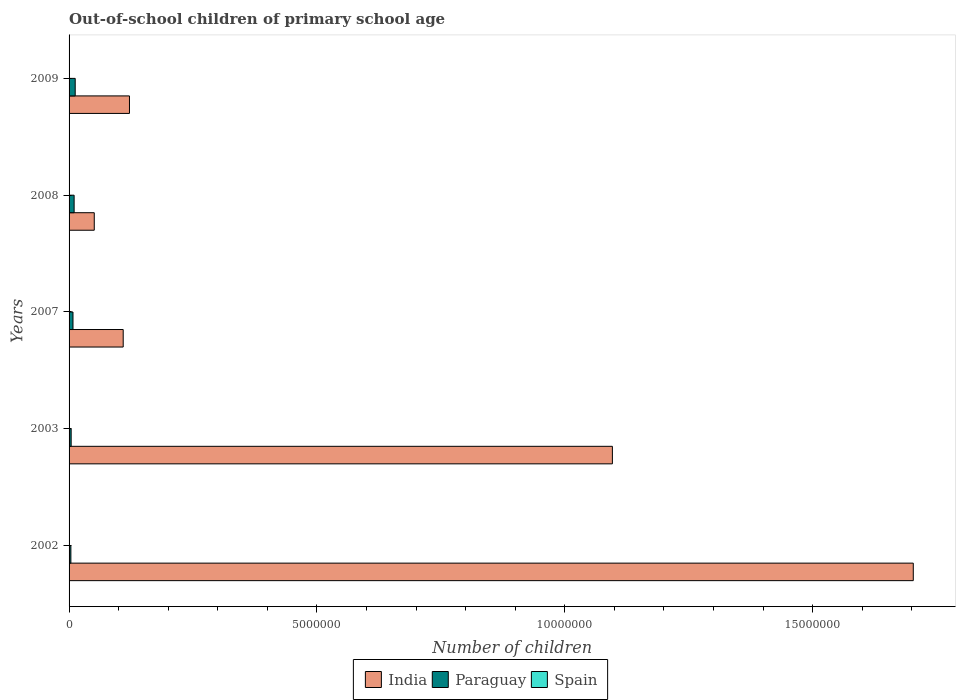How many groups of bars are there?
Offer a very short reply. 5. Are the number of bars per tick equal to the number of legend labels?
Your answer should be compact. Yes. Are the number of bars on each tick of the Y-axis equal?
Keep it short and to the point. Yes. How many bars are there on the 2nd tick from the top?
Provide a short and direct response. 3. How many bars are there on the 2nd tick from the bottom?
Keep it short and to the point. 3. What is the number of out-of-school children in India in 2002?
Make the answer very short. 1.70e+07. Across all years, what is the maximum number of out-of-school children in Paraguay?
Give a very brief answer. 1.24e+05. Across all years, what is the minimum number of out-of-school children in Spain?
Provide a succinct answer. 2757. In which year was the number of out-of-school children in India maximum?
Offer a terse response. 2002. What is the total number of out-of-school children in India in the graph?
Give a very brief answer. 3.08e+07. What is the difference between the number of out-of-school children in Paraguay in 2007 and that in 2009?
Offer a terse response. -4.46e+04. What is the difference between the number of out-of-school children in Paraguay in 2008 and the number of out-of-school children in India in 2002?
Make the answer very short. -1.69e+07. What is the average number of out-of-school children in India per year?
Offer a terse response. 6.16e+06. In the year 2002, what is the difference between the number of out-of-school children in India and number of out-of-school children in Paraguay?
Your response must be concise. 1.70e+07. In how many years, is the number of out-of-school children in Paraguay greater than 10000000 ?
Give a very brief answer. 0. What is the ratio of the number of out-of-school children in Spain in 2002 to that in 2007?
Keep it short and to the point. 0.52. Is the difference between the number of out-of-school children in India in 2003 and 2009 greater than the difference between the number of out-of-school children in Paraguay in 2003 and 2009?
Your response must be concise. Yes. What is the difference between the highest and the second highest number of out-of-school children in Paraguay?
Offer a very short reply. 2.17e+04. What is the difference between the highest and the lowest number of out-of-school children in Paraguay?
Your answer should be compact. 8.74e+04. In how many years, is the number of out-of-school children in India greater than the average number of out-of-school children in India taken over all years?
Offer a terse response. 2. Is the sum of the number of out-of-school children in India in 2002 and 2009 greater than the maximum number of out-of-school children in Spain across all years?
Your answer should be compact. Yes. What does the 3rd bar from the top in 2008 represents?
Ensure brevity in your answer.  India. What does the 3rd bar from the bottom in 2009 represents?
Ensure brevity in your answer.  Spain. How many bars are there?
Make the answer very short. 15. Are all the bars in the graph horizontal?
Offer a terse response. Yes. How many years are there in the graph?
Your response must be concise. 5. Does the graph contain any zero values?
Ensure brevity in your answer.  No. Where does the legend appear in the graph?
Offer a terse response. Bottom center. How many legend labels are there?
Make the answer very short. 3. What is the title of the graph?
Keep it short and to the point. Out-of-school children of primary school age. What is the label or title of the X-axis?
Provide a succinct answer. Number of children. What is the Number of children in India in 2002?
Provide a short and direct response. 1.70e+07. What is the Number of children of Paraguay in 2002?
Provide a short and direct response. 3.63e+04. What is the Number of children of Spain in 2002?
Your response must be concise. 2757. What is the Number of children in India in 2003?
Your response must be concise. 1.10e+07. What is the Number of children of Paraguay in 2003?
Ensure brevity in your answer.  4.20e+04. What is the Number of children in Spain in 2003?
Your response must be concise. 4811. What is the Number of children of India in 2007?
Provide a succinct answer. 1.09e+06. What is the Number of children in Paraguay in 2007?
Offer a terse response. 7.90e+04. What is the Number of children of Spain in 2007?
Provide a short and direct response. 5316. What is the Number of children of India in 2008?
Offer a very short reply. 5.08e+05. What is the Number of children in Paraguay in 2008?
Provide a short and direct response. 1.02e+05. What is the Number of children in Spain in 2008?
Give a very brief answer. 4170. What is the Number of children of India in 2009?
Provide a short and direct response. 1.22e+06. What is the Number of children of Paraguay in 2009?
Ensure brevity in your answer.  1.24e+05. What is the Number of children in Spain in 2009?
Keep it short and to the point. 2853. Across all years, what is the maximum Number of children in India?
Ensure brevity in your answer.  1.70e+07. Across all years, what is the maximum Number of children of Paraguay?
Provide a succinct answer. 1.24e+05. Across all years, what is the maximum Number of children of Spain?
Your response must be concise. 5316. Across all years, what is the minimum Number of children of India?
Give a very brief answer. 5.08e+05. Across all years, what is the minimum Number of children in Paraguay?
Offer a terse response. 3.63e+04. Across all years, what is the minimum Number of children in Spain?
Your answer should be compact. 2757. What is the total Number of children in India in the graph?
Give a very brief answer. 3.08e+07. What is the total Number of children in Paraguay in the graph?
Provide a succinct answer. 3.83e+05. What is the total Number of children in Spain in the graph?
Your response must be concise. 1.99e+04. What is the difference between the Number of children in India in 2002 and that in 2003?
Make the answer very short. 6.07e+06. What is the difference between the Number of children of Paraguay in 2002 and that in 2003?
Offer a very short reply. -5724. What is the difference between the Number of children in Spain in 2002 and that in 2003?
Provide a succinct answer. -2054. What is the difference between the Number of children in India in 2002 and that in 2007?
Provide a short and direct response. 1.59e+07. What is the difference between the Number of children in Paraguay in 2002 and that in 2007?
Give a very brief answer. -4.28e+04. What is the difference between the Number of children of Spain in 2002 and that in 2007?
Provide a short and direct response. -2559. What is the difference between the Number of children in India in 2002 and that in 2008?
Your response must be concise. 1.65e+07. What is the difference between the Number of children in Paraguay in 2002 and that in 2008?
Provide a short and direct response. -6.57e+04. What is the difference between the Number of children of Spain in 2002 and that in 2008?
Offer a very short reply. -1413. What is the difference between the Number of children in India in 2002 and that in 2009?
Keep it short and to the point. 1.58e+07. What is the difference between the Number of children in Paraguay in 2002 and that in 2009?
Provide a succinct answer. -8.74e+04. What is the difference between the Number of children in Spain in 2002 and that in 2009?
Offer a very short reply. -96. What is the difference between the Number of children in India in 2003 and that in 2007?
Provide a short and direct response. 9.87e+06. What is the difference between the Number of children in Paraguay in 2003 and that in 2007?
Your answer should be compact. -3.70e+04. What is the difference between the Number of children of Spain in 2003 and that in 2007?
Your answer should be very brief. -505. What is the difference between the Number of children in India in 2003 and that in 2008?
Offer a terse response. 1.05e+07. What is the difference between the Number of children in Paraguay in 2003 and that in 2008?
Provide a short and direct response. -5.99e+04. What is the difference between the Number of children in Spain in 2003 and that in 2008?
Offer a terse response. 641. What is the difference between the Number of children in India in 2003 and that in 2009?
Give a very brief answer. 9.74e+06. What is the difference between the Number of children of Paraguay in 2003 and that in 2009?
Provide a succinct answer. -8.16e+04. What is the difference between the Number of children of Spain in 2003 and that in 2009?
Keep it short and to the point. 1958. What is the difference between the Number of children in India in 2007 and that in 2008?
Ensure brevity in your answer.  5.84e+05. What is the difference between the Number of children of Paraguay in 2007 and that in 2008?
Offer a very short reply. -2.29e+04. What is the difference between the Number of children of Spain in 2007 and that in 2008?
Offer a very short reply. 1146. What is the difference between the Number of children of India in 2007 and that in 2009?
Provide a succinct answer. -1.26e+05. What is the difference between the Number of children in Paraguay in 2007 and that in 2009?
Your response must be concise. -4.46e+04. What is the difference between the Number of children of Spain in 2007 and that in 2009?
Give a very brief answer. 2463. What is the difference between the Number of children in India in 2008 and that in 2009?
Provide a short and direct response. -7.10e+05. What is the difference between the Number of children of Paraguay in 2008 and that in 2009?
Give a very brief answer. -2.17e+04. What is the difference between the Number of children of Spain in 2008 and that in 2009?
Keep it short and to the point. 1317. What is the difference between the Number of children in India in 2002 and the Number of children in Paraguay in 2003?
Keep it short and to the point. 1.70e+07. What is the difference between the Number of children in India in 2002 and the Number of children in Spain in 2003?
Your answer should be very brief. 1.70e+07. What is the difference between the Number of children in Paraguay in 2002 and the Number of children in Spain in 2003?
Your response must be concise. 3.15e+04. What is the difference between the Number of children in India in 2002 and the Number of children in Paraguay in 2007?
Your answer should be very brief. 1.70e+07. What is the difference between the Number of children in India in 2002 and the Number of children in Spain in 2007?
Your response must be concise. 1.70e+07. What is the difference between the Number of children of Paraguay in 2002 and the Number of children of Spain in 2007?
Provide a short and direct response. 3.10e+04. What is the difference between the Number of children of India in 2002 and the Number of children of Paraguay in 2008?
Give a very brief answer. 1.69e+07. What is the difference between the Number of children in India in 2002 and the Number of children in Spain in 2008?
Offer a terse response. 1.70e+07. What is the difference between the Number of children of Paraguay in 2002 and the Number of children of Spain in 2008?
Your answer should be compact. 3.21e+04. What is the difference between the Number of children in India in 2002 and the Number of children in Paraguay in 2009?
Keep it short and to the point. 1.69e+07. What is the difference between the Number of children in India in 2002 and the Number of children in Spain in 2009?
Ensure brevity in your answer.  1.70e+07. What is the difference between the Number of children in Paraguay in 2002 and the Number of children in Spain in 2009?
Your response must be concise. 3.34e+04. What is the difference between the Number of children of India in 2003 and the Number of children of Paraguay in 2007?
Make the answer very short. 1.09e+07. What is the difference between the Number of children of India in 2003 and the Number of children of Spain in 2007?
Make the answer very short. 1.10e+07. What is the difference between the Number of children in Paraguay in 2003 and the Number of children in Spain in 2007?
Make the answer very short. 3.67e+04. What is the difference between the Number of children of India in 2003 and the Number of children of Paraguay in 2008?
Make the answer very short. 1.09e+07. What is the difference between the Number of children of India in 2003 and the Number of children of Spain in 2008?
Provide a succinct answer. 1.10e+07. What is the difference between the Number of children of Paraguay in 2003 and the Number of children of Spain in 2008?
Offer a terse response. 3.79e+04. What is the difference between the Number of children of India in 2003 and the Number of children of Paraguay in 2009?
Your answer should be compact. 1.08e+07. What is the difference between the Number of children in India in 2003 and the Number of children in Spain in 2009?
Make the answer very short. 1.10e+07. What is the difference between the Number of children in Paraguay in 2003 and the Number of children in Spain in 2009?
Offer a very short reply. 3.92e+04. What is the difference between the Number of children in India in 2007 and the Number of children in Paraguay in 2008?
Offer a very short reply. 9.90e+05. What is the difference between the Number of children of India in 2007 and the Number of children of Spain in 2008?
Provide a succinct answer. 1.09e+06. What is the difference between the Number of children of Paraguay in 2007 and the Number of children of Spain in 2008?
Keep it short and to the point. 7.49e+04. What is the difference between the Number of children in India in 2007 and the Number of children in Paraguay in 2009?
Ensure brevity in your answer.  9.68e+05. What is the difference between the Number of children in India in 2007 and the Number of children in Spain in 2009?
Make the answer very short. 1.09e+06. What is the difference between the Number of children in Paraguay in 2007 and the Number of children in Spain in 2009?
Provide a short and direct response. 7.62e+04. What is the difference between the Number of children in India in 2008 and the Number of children in Paraguay in 2009?
Offer a very short reply. 3.84e+05. What is the difference between the Number of children of India in 2008 and the Number of children of Spain in 2009?
Offer a terse response. 5.05e+05. What is the difference between the Number of children in Paraguay in 2008 and the Number of children in Spain in 2009?
Keep it short and to the point. 9.91e+04. What is the average Number of children of India per year?
Make the answer very short. 6.16e+06. What is the average Number of children of Paraguay per year?
Offer a terse response. 7.66e+04. What is the average Number of children of Spain per year?
Offer a terse response. 3981.4. In the year 2002, what is the difference between the Number of children in India and Number of children in Paraguay?
Give a very brief answer. 1.70e+07. In the year 2002, what is the difference between the Number of children in India and Number of children in Spain?
Make the answer very short. 1.70e+07. In the year 2002, what is the difference between the Number of children in Paraguay and Number of children in Spain?
Provide a short and direct response. 3.35e+04. In the year 2003, what is the difference between the Number of children of India and Number of children of Paraguay?
Your response must be concise. 1.09e+07. In the year 2003, what is the difference between the Number of children of India and Number of children of Spain?
Keep it short and to the point. 1.10e+07. In the year 2003, what is the difference between the Number of children of Paraguay and Number of children of Spain?
Provide a succinct answer. 3.72e+04. In the year 2007, what is the difference between the Number of children in India and Number of children in Paraguay?
Your answer should be compact. 1.01e+06. In the year 2007, what is the difference between the Number of children in India and Number of children in Spain?
Ensure brevity in your answer.  1.09e+06. In the year 2007, what is the difference between the Number of children of Paraguay and Number of children of Spain?
Offer a very short reply. 7.37e+04. In the year 2008, what is the difference between the Number of children in India and Number of children in Paraguay?
Make the answer very short. 4.06e+05. In the year 2008, what is the difference between the Number of children of India and Number of children of Spain?
Give a very brief answer. 5.04e+05. In the year 2008, what is the difference between the Number of children of Paraguay and Number of children of Spain?
Offer a very short reply. 9.78e+04. In the year 2009, what is the difference between the Number of children of India and Number of children of Paraguay?
Give a very brief answer. 1.09e+06. In the year 2009, what is the difference between the Number of children of India and Number of children of Spain?
Your response must be concise. 1.22e+06. In the year 2009, what is the difference between the Number of children in Paraguay and Number of children in Spain?
Ensure brevity in your answer.  1.21e+05. What is the ratio of the Number of children of India in 2002 to that in 2003?
Give a very brief answer. 1.55. What is the ratio of the Number of children of Paraguay in 2002 to that in 2003?
Provide a succinct answer. 0.86. What is the ratio of the Number of children of Spain in 2002 to that in 2003?
Offer a very short reply. 0.57. What is the ratio of the Number of children in India in 2002 to that in 2007?
Your answer should be compact. 15.6. What is the ratio of the Number of children of Paraguay in 2002 to that in 2007?
Offer a very short reply. 0.46. What is the ratio of the Number of children in Spain in 2002 to that in 2007?
Offer a terse response. 0.52. What is the ratio of the Number of children in India in 2002 to that in 2008?
Your answer should be very brief. 33.52. What is the ratio of the Number of children of Paraguay in 2002 to that in 2008?
Provide a succinct answer. 0.36. What is the ratio of the Number of children of Spain in 2002 to that in 2008?
Give a very brief answer. 0.66. What is the ratio of the Number of children of India in 2002 to that in 2009?
Offer a very short reply. 13.98. What is the ratio of the Number of children in Paraguay in 2002 to that in 2009?
Ensure brevity in your answer.  0.29. What is the ratio of the Number of children of Spain in 2002 to that in 2009?
Keep it short and to the point. 0.97. What is the ratio of the Number of children in India in 2003 to that in 2007?
Offer a very short reply. 10.04. What is the ratio of the Number of children in Paraguay in 2003 to that in 2007?
Provide a short and direct response. 0.53. What is the ratio of the Number of children of Spain in 2003 to that in 2007?
Offer a terse response. 0.91. What is the ratio of the Number of children of India in 2003 to that in 2008?
Make the answer very short. 21.57. What is the ratio of the Number of children in Paraguay in 2003 to that in 2008?
Your answer should be very brief. 0.41. What is the ratio of the Number of children in Spain in 2003 to that in 2008?
Provide a succinct answer. 1.15. What is the ratio of the Number of children of India in 2003 to that in 2009?
Give a very brief answer. 9. What is the ratio of the Number of children in Paraguay in 2003 to that in 2009?
Your answer should be compact. 0.34. What is the ratio of the Number of children in Spain in 2003 to that in 2009?
Keep it short and to the point. 1.69. What is the ratio of the Number of children of India in 2007 to that in 2008?
Ensure brevity in your answer.  2.15. What is the ratio of the Number of children of Paraguay in 2007 to that in 2008?
Provide a short and direct response. 0.78. What is the ratio of the Number of children of Spain in 2007 to that in 2008?
Your answer should be very brief. 1.27. What is the ratio of the Number of children of India in 2007 to that in 2009?
Make the answer very short. 0.9. What is the ratio of the Number of children of Paraguay in 2007 to that in 2009?
Keep it short and to the point. 0.64. What is the ratio of the Number of children in Spain in 2007 to that in 2009?
Give a very brief answer. 1.86. What is the ratio of the Number of children in India in 2008 to that in 2009?
Keep it short and to the point. 0.42. What is the ratio of the Number of children of Paraguay in 2008 to that in 2009?
Offer a terse response. 0.82. What is the ratio of the Number of children in Spain in 2008 to that in 2009?
Make the answer very short. 1.46. What is the difference between the highest and the second highest Number of children in India?
Ensure brevity in your answer.  6.07e+06. What is the difference between the highest and the second highest Number of children in Paraguay?
Offer a very short reply. 2.17e+04. What is the difference between the highest and the second highest Number of children in Spain?
Provide a succinct answer. 505. What is the difference between the highest and the lowest Number of children in India?
Your response must be concise. 1.65e+07. What is the difference between the highest and the lowest Number of children in Paraguay?
Give a very brief answer. 8.74e+04. What is the difference between the highest and the lowest Number of children in Spain?
Offer a terse response. 2559. 